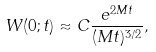Convert formula to latex. <formula><loc_0><loc_0><loc_500><loc_500>W ( 0 ; t ) \approx C \frac { e ^ { 2 M t } } { ( M t ) ^ { 3 / 2 } } ,</formula> 